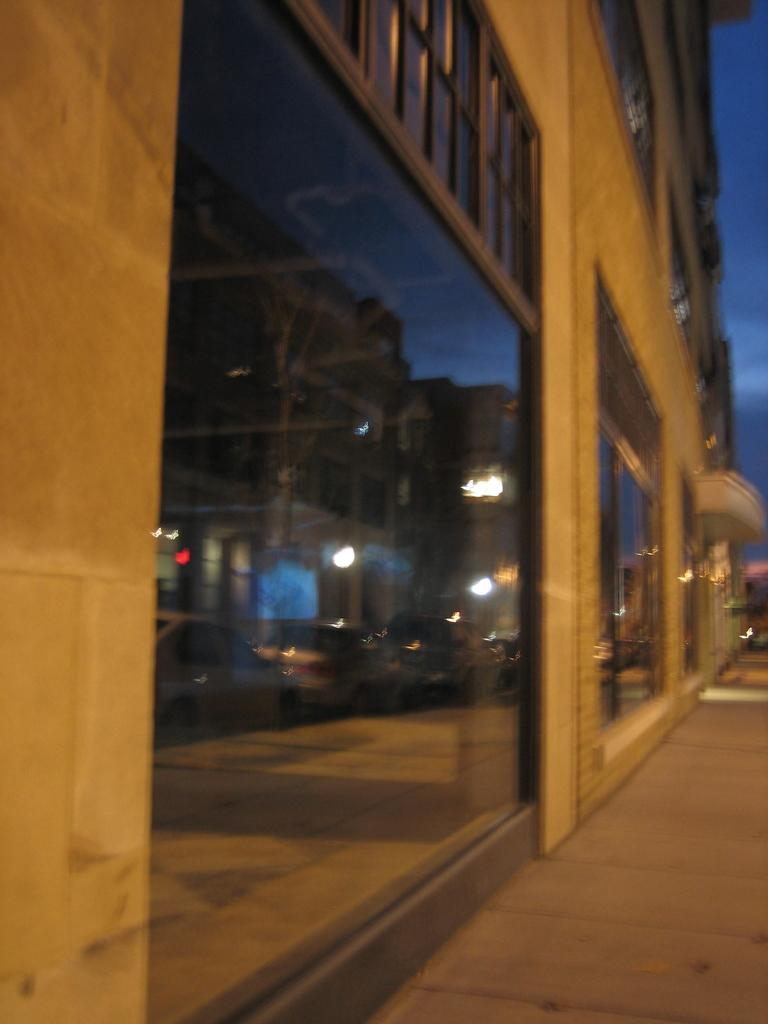What type of structure is visible in the image? There is a building in the image. What feature can be observed on the building? The building has glass windows. How many girls are holding a rod in the image? There are no girls or rods present in the image; it only features a building with glass windows. 